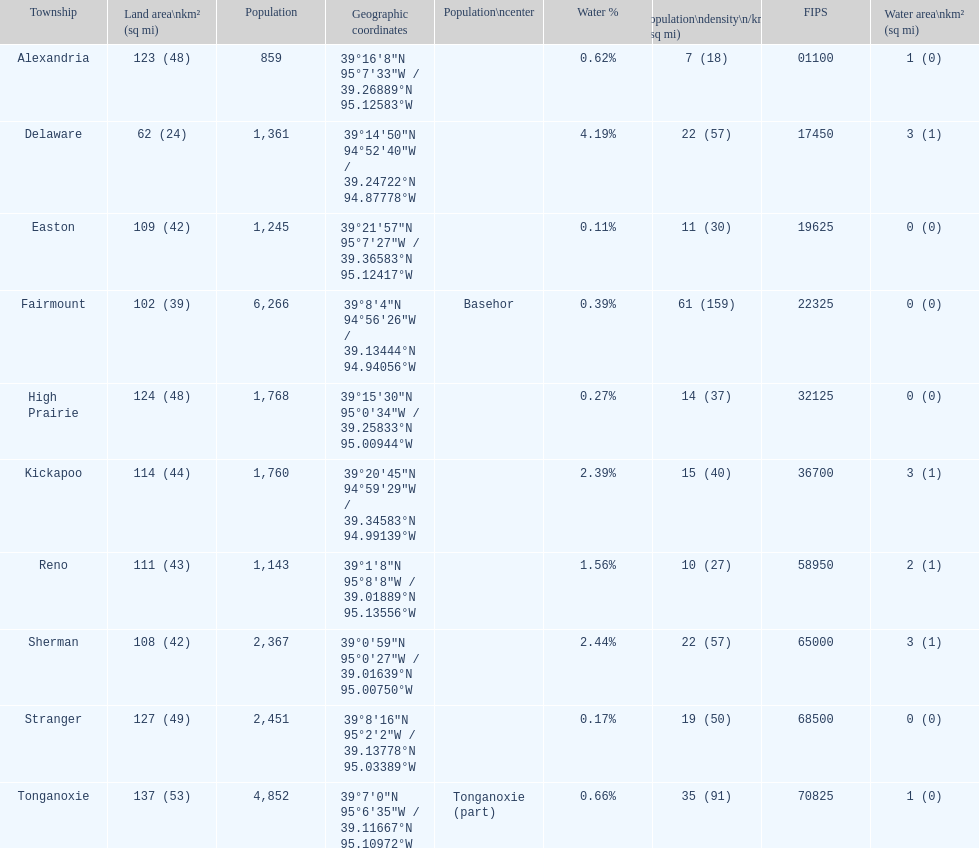What is the difference of population in easton and reno? 102. 